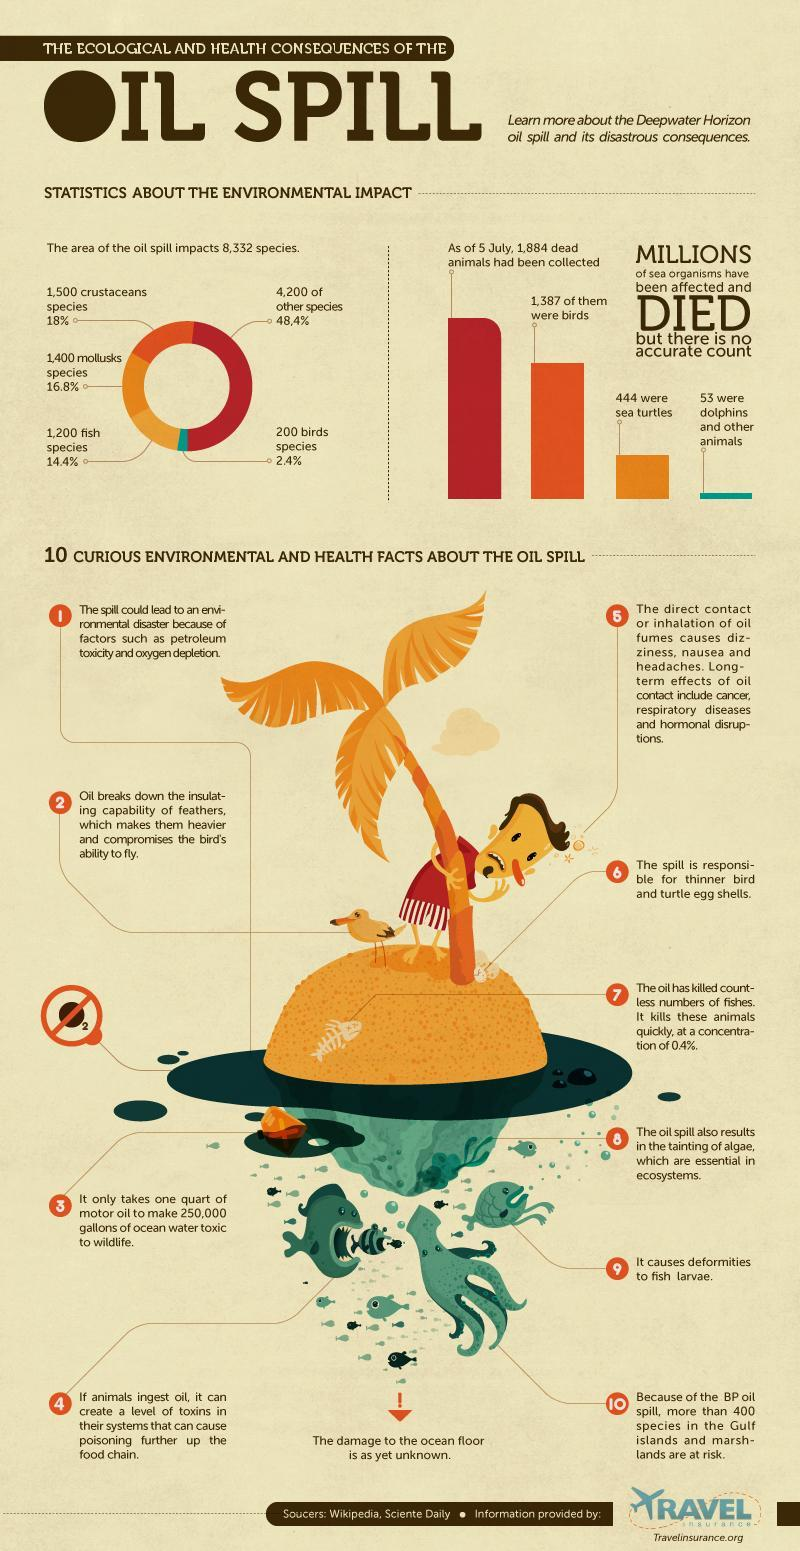what is the percentage of crustaceans and mollusk species among all the other species that are being affected by oil spill?
Answer the question with a short phrase. 34.8% which animal was the most among dead animals that had been collected as of July 5? birds what is the number of dead animals other than birds, that had been collected as of July 5? 497 what is the percentage of fish and bird species among all the other species that are being affected by oil spill? 16.8% what is the percentage of fish and mollusk species among all the other species that are being affected by oil spill? 31.2% what is the 9th fact about oil spill in the list? it causes deformities to fish larvae what is the total number of crustaceans and mollusk species that are being affected by oil spill? 2900 